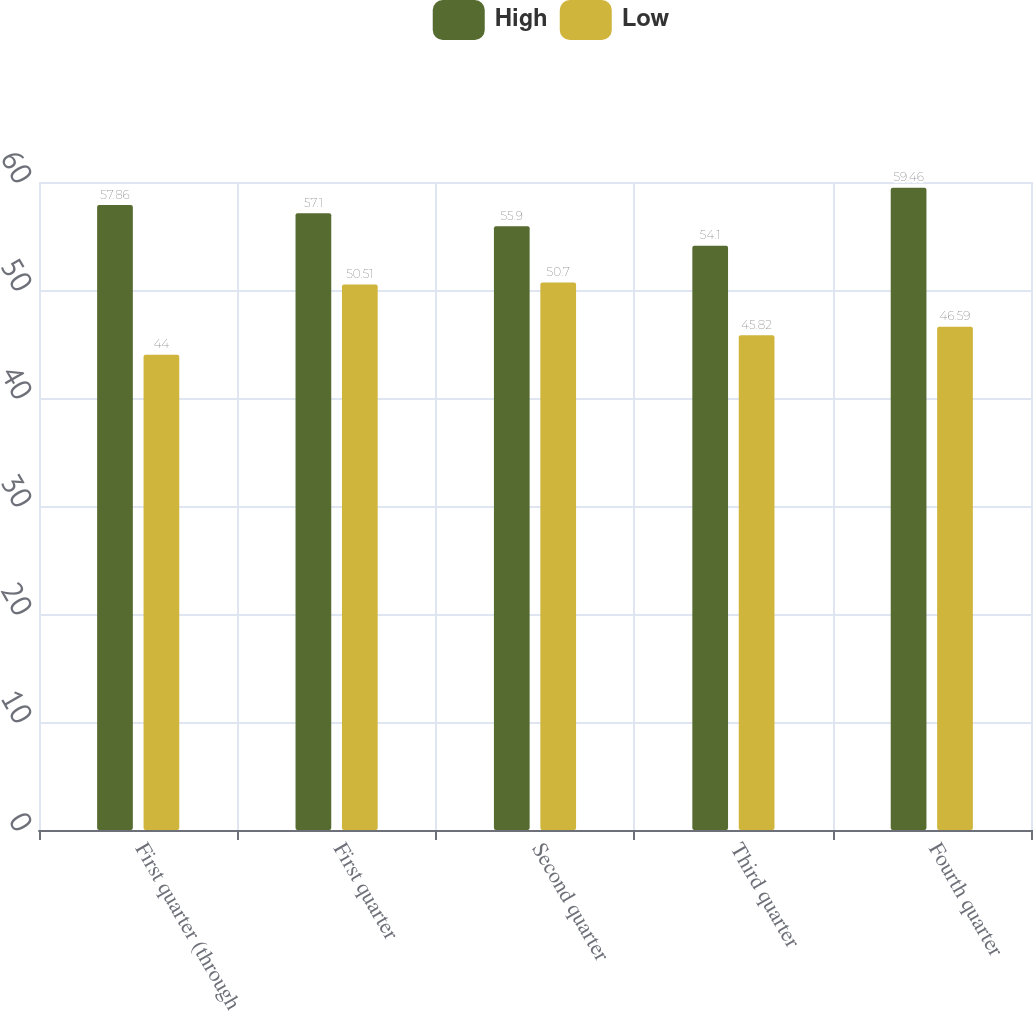<chart> <loc_0><loc_0><loc_500><loc_500><stacked_bar_chart><ecel><fcel>First quarter (through<fcel>First quarter<fcel>Second quarter<fcel>Third quarter<fcel>Fourth quarter<nl><fcel>High<fcel>57.86<fcel>57.1<fcel>55.9<fcel>54.1<fcel>59.46<nl><fcel>Low<fcel>44<fcel>50.51<fcel>50.7<fcel>45.82<fcel>46.59<nl></chart> 